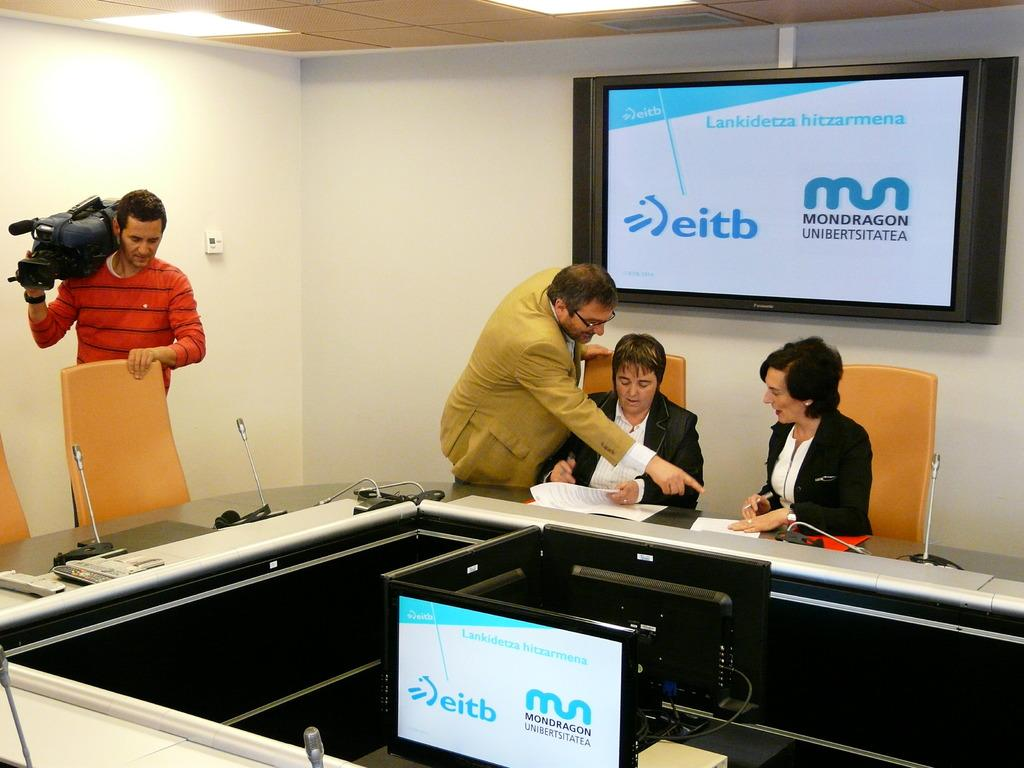<image>
Render a clear and concise summary of the photo. Three people are going over some papers about eitb 